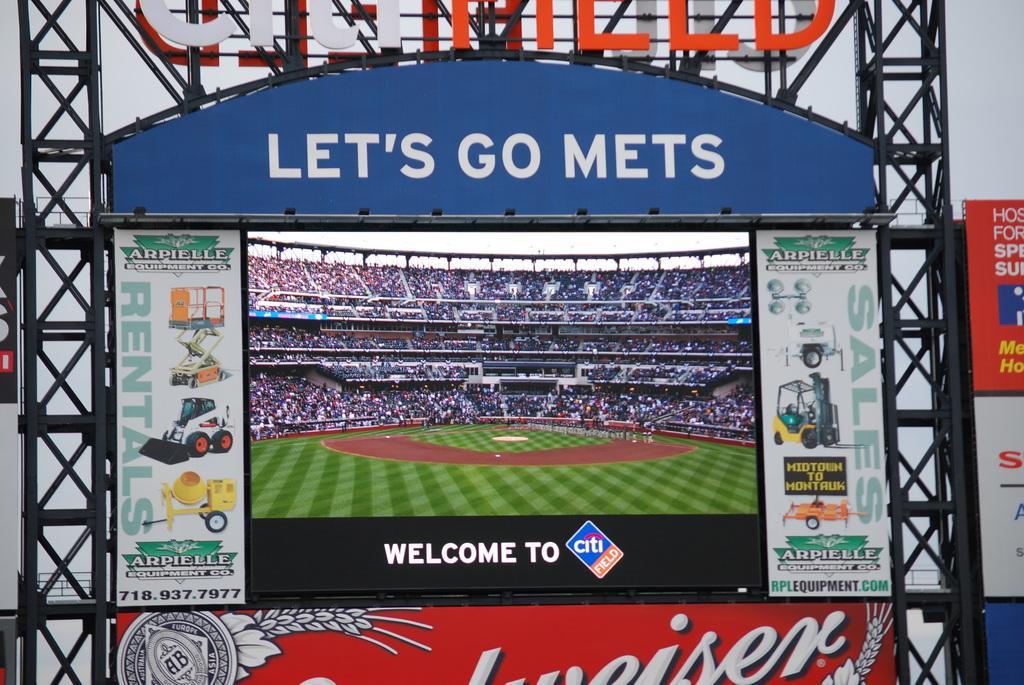Please provide a concise description of this image. Screen is attached to this rods. Around this screen there are hoardings. In this screen we can see people. 